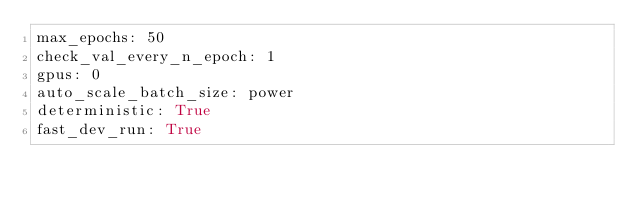<code> <loc_0><loc_0><loc_500><loc_500><_YAML_>max_epochs: 50
check_val_every_n_epoch: 1
gpus: 0
auto_scale_batch_size: power
deterministic: True
fast_dev_run: True
</code> 